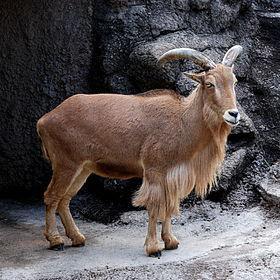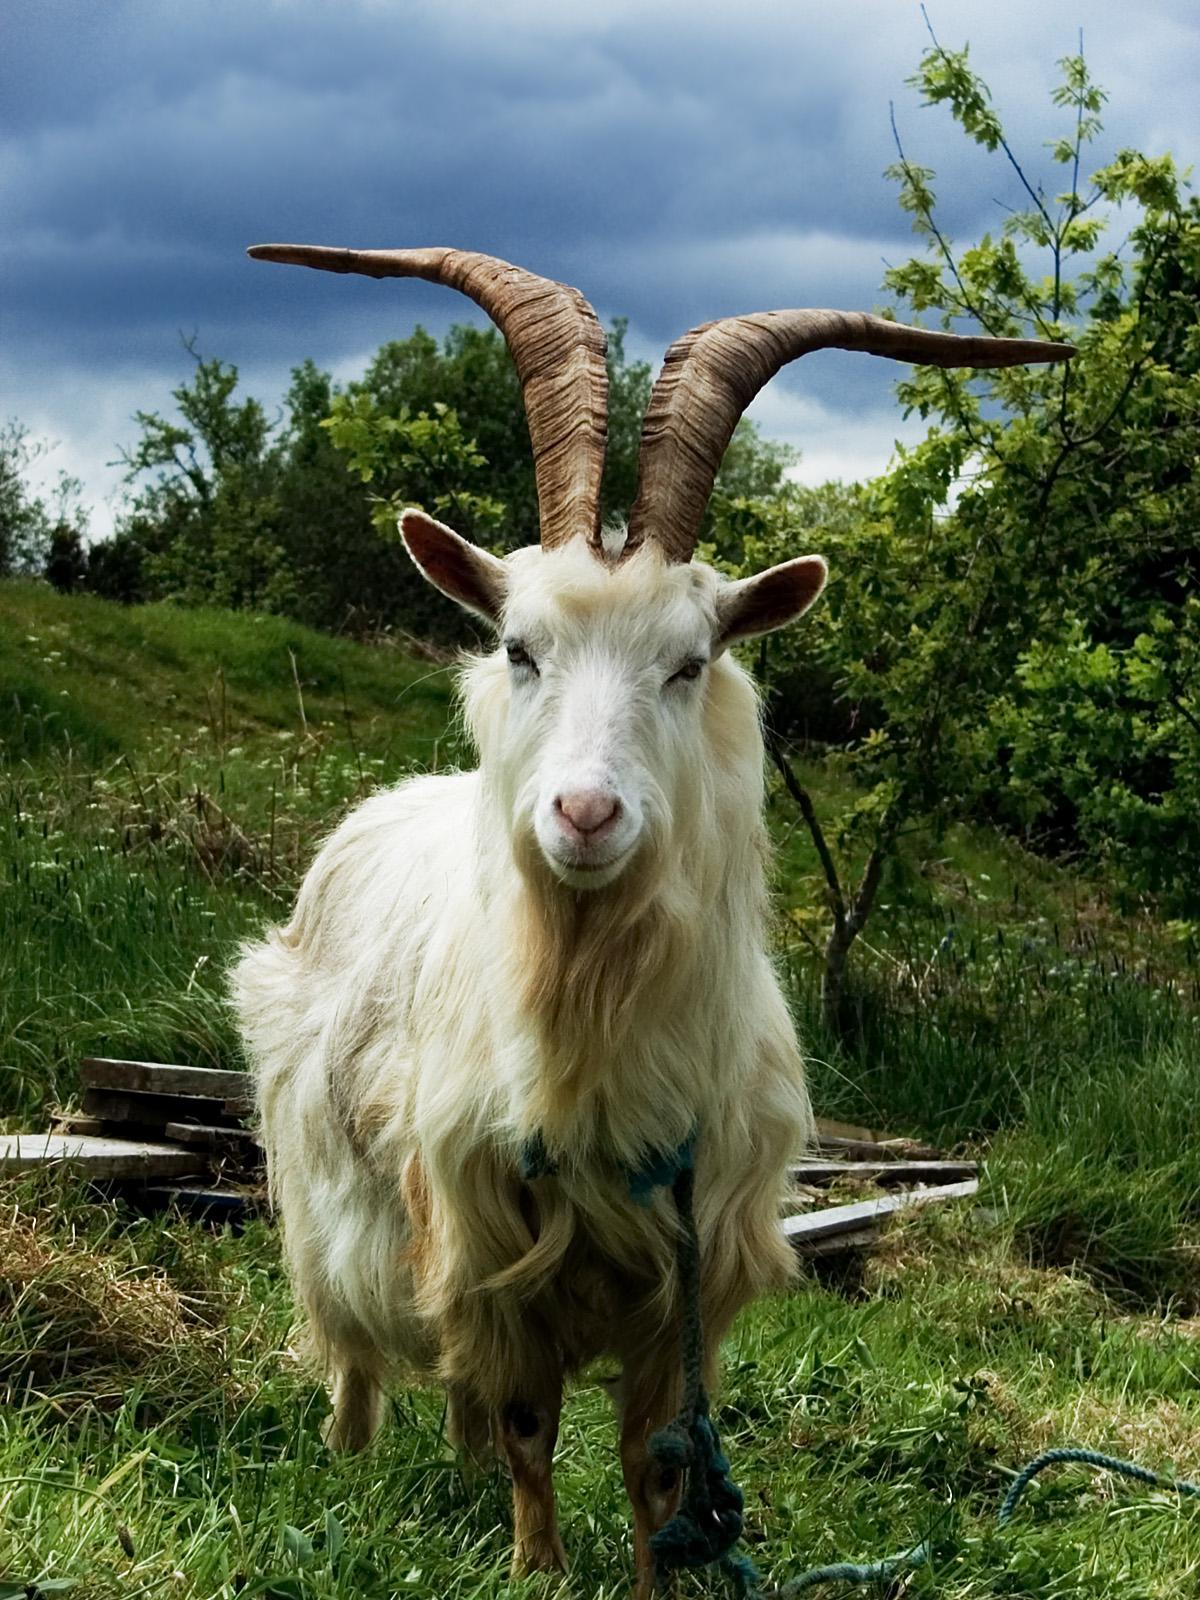The first image is the image on the left, the second image is the image on the right. Given the left and right images, does the statement "An ibex is laying down in the left image." hold true? Answer yes or no. No. The first image is the image on the left, the second image is the image on the right. For the images shown, is this caption "The left image contains one reclining long-horned goat, and the right image contains one long-horned goat standing in profile." true? Answer yes or no. No. 